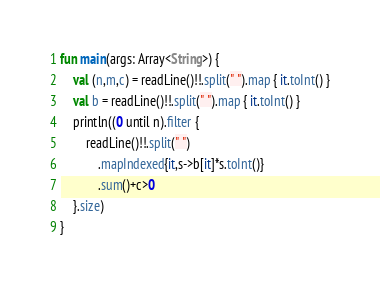Convert code to text. <code><loc_0><loc_0><loc_500><loc_500><_Kotlin_>fun main(args: Array<String>) {
    val (n,m,c) = readLine()!!.split(" ").map { it.toInt() }
    val b = readLine()!!.split(" ").map { it.toInt() }
    println((0 until n).filter {
        readLine()!!.split(" ")
            .mapIndexed{it,s->b[it]*s.toInt()}
            .sum()+c>0
    }.size)
}</code> 